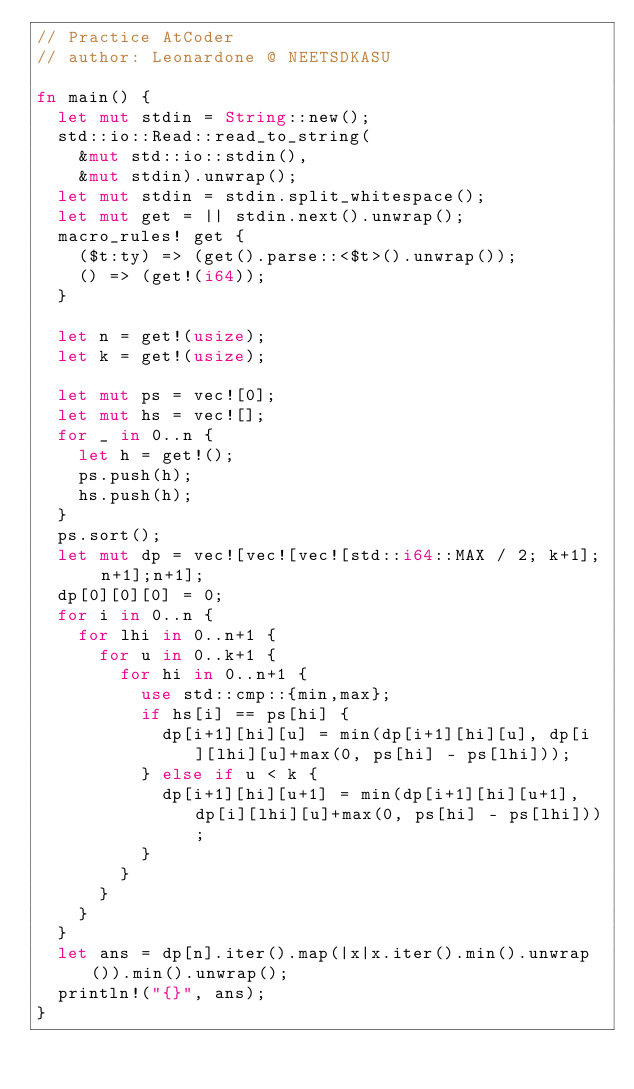<code> <loc_0><loc_0><loc_500><loc_500><_Rust_>// Practice AtCoder
// author: Leonardone @ NEETSDKASU

fn main() {
  let mut stdin = String::new();
  std::io::Read::read_to_string(
    &mut std::io::stdin(),
    &mut stdin).unwrap();
  let mut stdin = stdin.split_whitespace();
  let mut get = || stdin.next().unwrap();
  macro_rules! get {
    ($t:ty) => (get().parse::<$t>().unwrap());
    () => (get!(i64));
  }
  
  let n = get!(usize);
  let k = get!(usize);
  
  let mut ps = vec![0];
  let mut hs = vec![];
  for _ in 0..n {
    let h = get!();
    ps.push(h);
    hs.push(h);
  }
  ps.sort();
  let mut dp = vec![vec![vec![std::i64::MAX / 2; k+1]; n+1];n+1];
  dp[0][0][0] = 0;
  for i in 0..n {
    for lhi in 0..n+1 {
      for u in 0..k+1 {
        for hi in 0..n+1 {
          use std::cmp::{min,max};
          if hs[i] == ps[hi] {
            dp[i+1][hi][u] = min(dp[i+1][hi][u], dp[i][lhi][u]+max(0, ps[hi] - ps[lhi]));
          } else if u < k {
            dp[i+1][hi][u+1] = min(dp[i+1][hi][u+1], dp[i][lhi][u]+max(0, ps[hi] - ps[lhi]));
          }
        }
      }
    }
  }
  let ans = dp[n].iter().map(|x|x.iter().min().unwrap()).min().unwrap();
  println!("{}", ans);
}</code> 